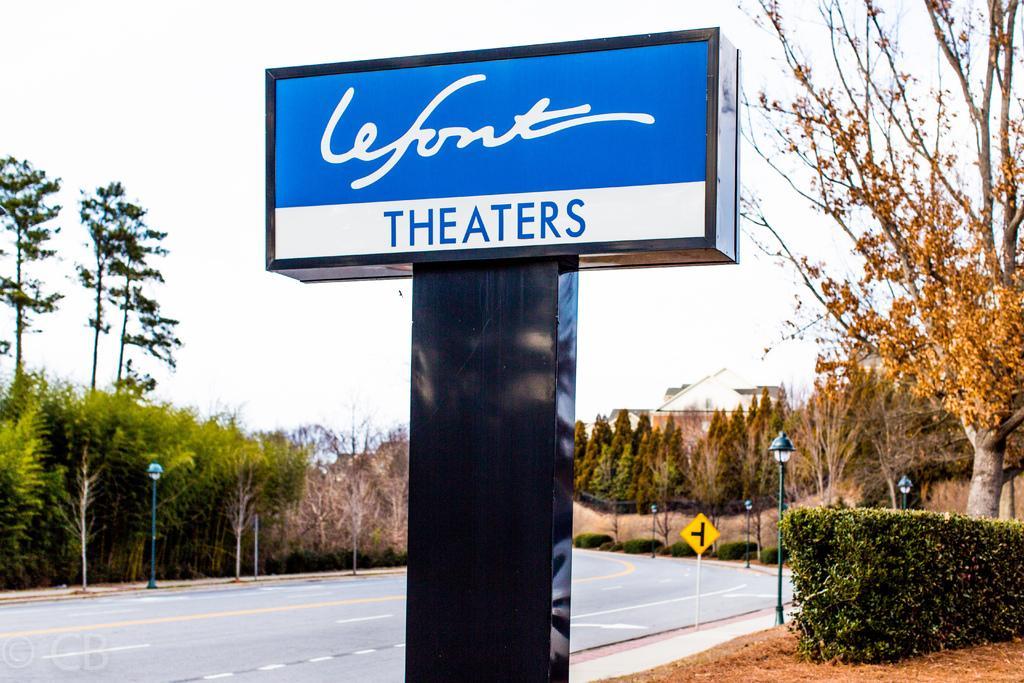How would you summarize this image in a sentence or two? There is a road. Here we can see poles, lights, boards, plants, and trees. In the background there is sky. 